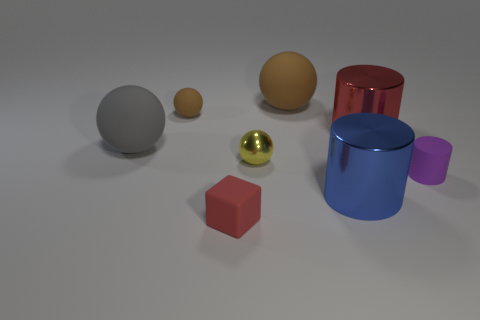Subtract all large metal cylinders. How many cylinders are left? 1 Subtract all brown blocks. How many brown spheres are left? 2 Add 1 small purple things. How many objects exist? 9 Subtract all blocks. How many objects are left? 7 Subtract all yellow balls. How many balls are left? 3 Subtract 1 cylinders. How many cylinders are left? 2 Subtract all purple cylinders. Subtract all green balls. How many cylinders are left? 2 Subtract all red metal things. Subtract all small metal spheres. How many objects are left? 6 Add 5 small cylinders. How many small cylinders are left? 6 Add 2 big gray balls. How many big gray balls exist? 3 